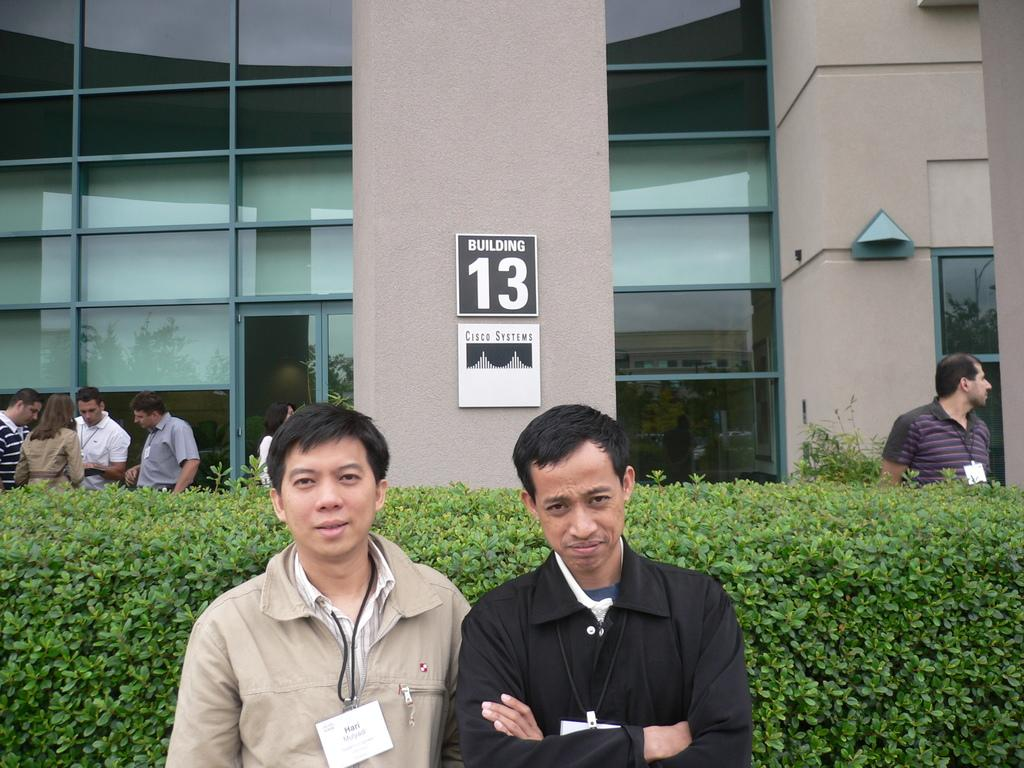How many men are present in the image? There are two men in the image. What is the facial expression of the men? The men are smiling. What can be seen in the background of the image? There are people, at least one building, trees, and boards in the background of the image. What type of bone can be seen in the image? There is no bone present in the image. How many leaves are visible on the trees in the image? The image does not provide a close enough view of the trees to count individual leaves. 